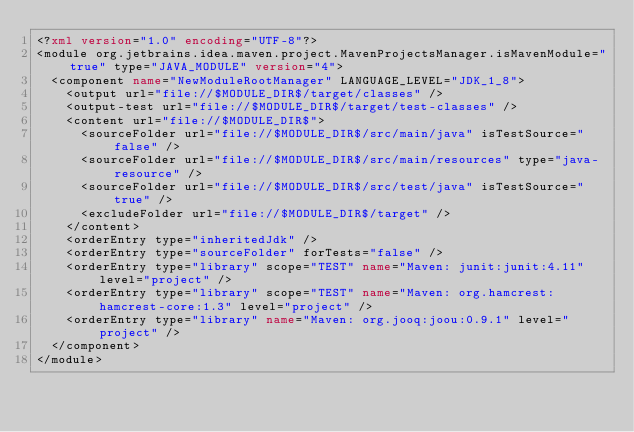Convert code to text. <code><loc_0><loc_0><loc_500><loc_500><_XML_><?xml version="1.0" encoding="UTF-8"?>
<module org.jetbrains.idea.maven.project.MavenProjectsManager.isMavenModule="true" type="JAVA_MODULE" version="4">
  <component name="NewModuleRootManager" LANGUAGE_LEVEL="JDK_1_8">
    <output url="file://$MODULE_DIR$/target/classes" />
    <output-test url="file://$MODULE_DIR$/target/test-classes" />
    <content url="file://$MODULE_DIR$">
      <sourceFolder url="file://$MODULE_DIR$/src/main/java" isTestSource="false" />
      <sourceFolder url="file://$MODULE_DIR$/src/main/resources" type="java-resource" />
      <sourceFolder url="file://$MODULE_DIR$/src/test/java" isTestSource="true" />
      <excludeFolder url="file://$MODULE_DIR$/target" />
    </content>
    <orderEntry type="inheritedJdk" />
    <orderEntry type="sourceFolder" forTests="false" />
    <orderEntry type="library" scope="TEST" name="Maven: junit:junit:4.11" level="project" />
    <orderEntry type="library" scope="TEST" name="Maven: org.hamcrest:hamcrest-core:1.3" level="project" />
    <orderEntry type="library" name="Maven: org.jooq:joou:0.9.1" level="project" />
  </component>
</module></code> 